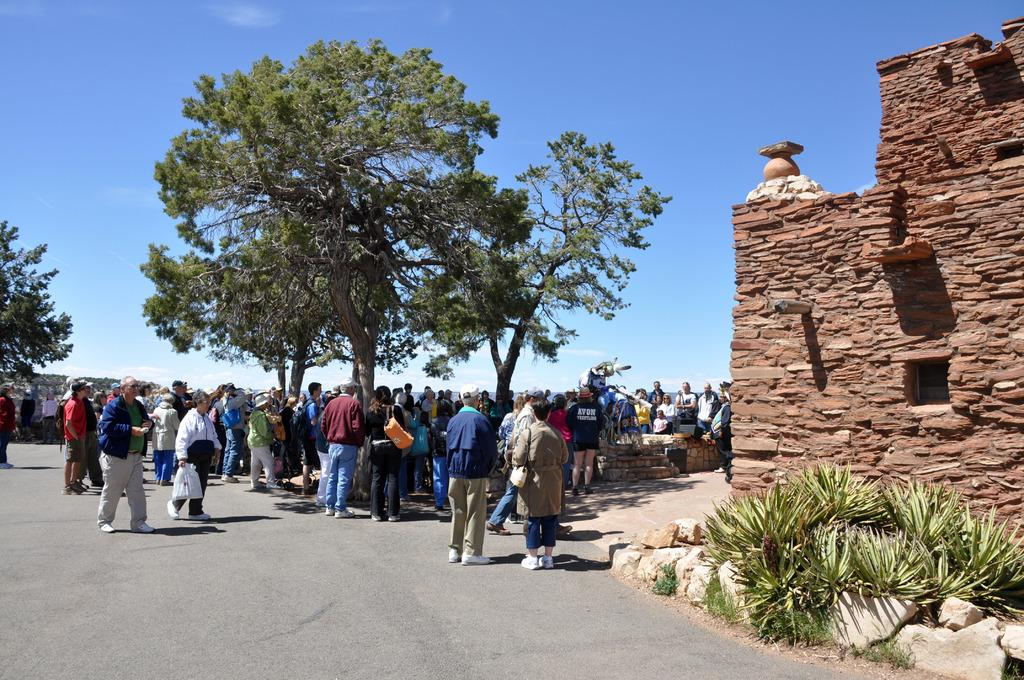What can be observed about the people in the image? There are people standing in the image, and some of them are carrying bags. What is the background of the image like? There is a wall in the image, along with plants, trees, and the sky. Can you describe the vegetation in the image? There are plants and trees visible in the image. What color of paint is being used on the building in the image? There is no building present in the image, so it is not possible to determine the color of paint being used. How many heads are visible in the image? The question about heads is irrelevant to the image, as it does not mention or depict any human or animal body parts. 